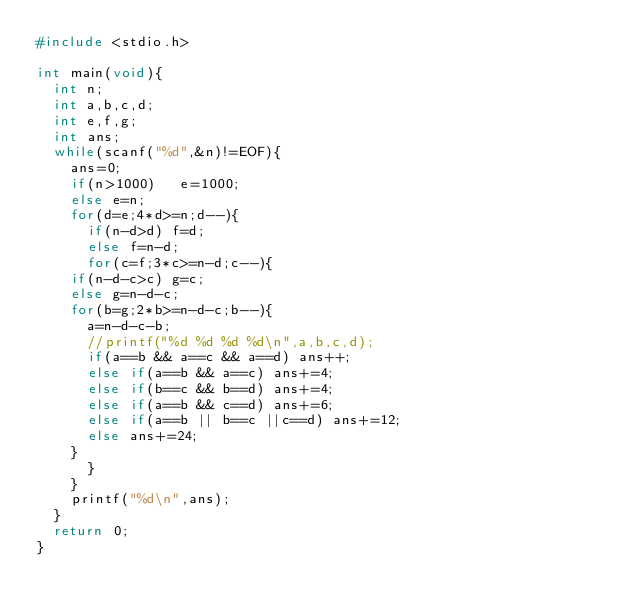Convert code to text. <code><loc_0><loc_0><loc_500><loc_500><_C_>#include <stdio.h>

int main(void){
  int n;
  int a,b,c,d;
  int e,f,g;
  int ans;
  while(scanf("%d",&n)!=EOF){
    ans=0;
    if(n>1000)   e=1000;
    else e=n;
    for(d=e;4*d>=n;d--){
      if(n-d>d) f=d;
      else f=n-d;
      for(c=f;3*c>=n-d;c--){
	if(n-d-c>c) g=c;
	else g=n-d-c;
	for(b=g;2*b>=n-d-c;b--){
	  a=n-d-c-b;
	  //printf("%d %d %d %d\n",a,b,c,d);
	  if(a==b && a==c && a==d) ans++;
	  else if(a==b && a==c) ans+=4;
	  else if(b==c && b==d) ans+=4;
	  else if(a==b && c==d) ans+=6;
	  else if(a==b || b==c ||c==d) ans+=12;
	  else ans+=24;
	}
      }
    }
    printf("%d\n",ans);
  }
  return 0;
}</code> 